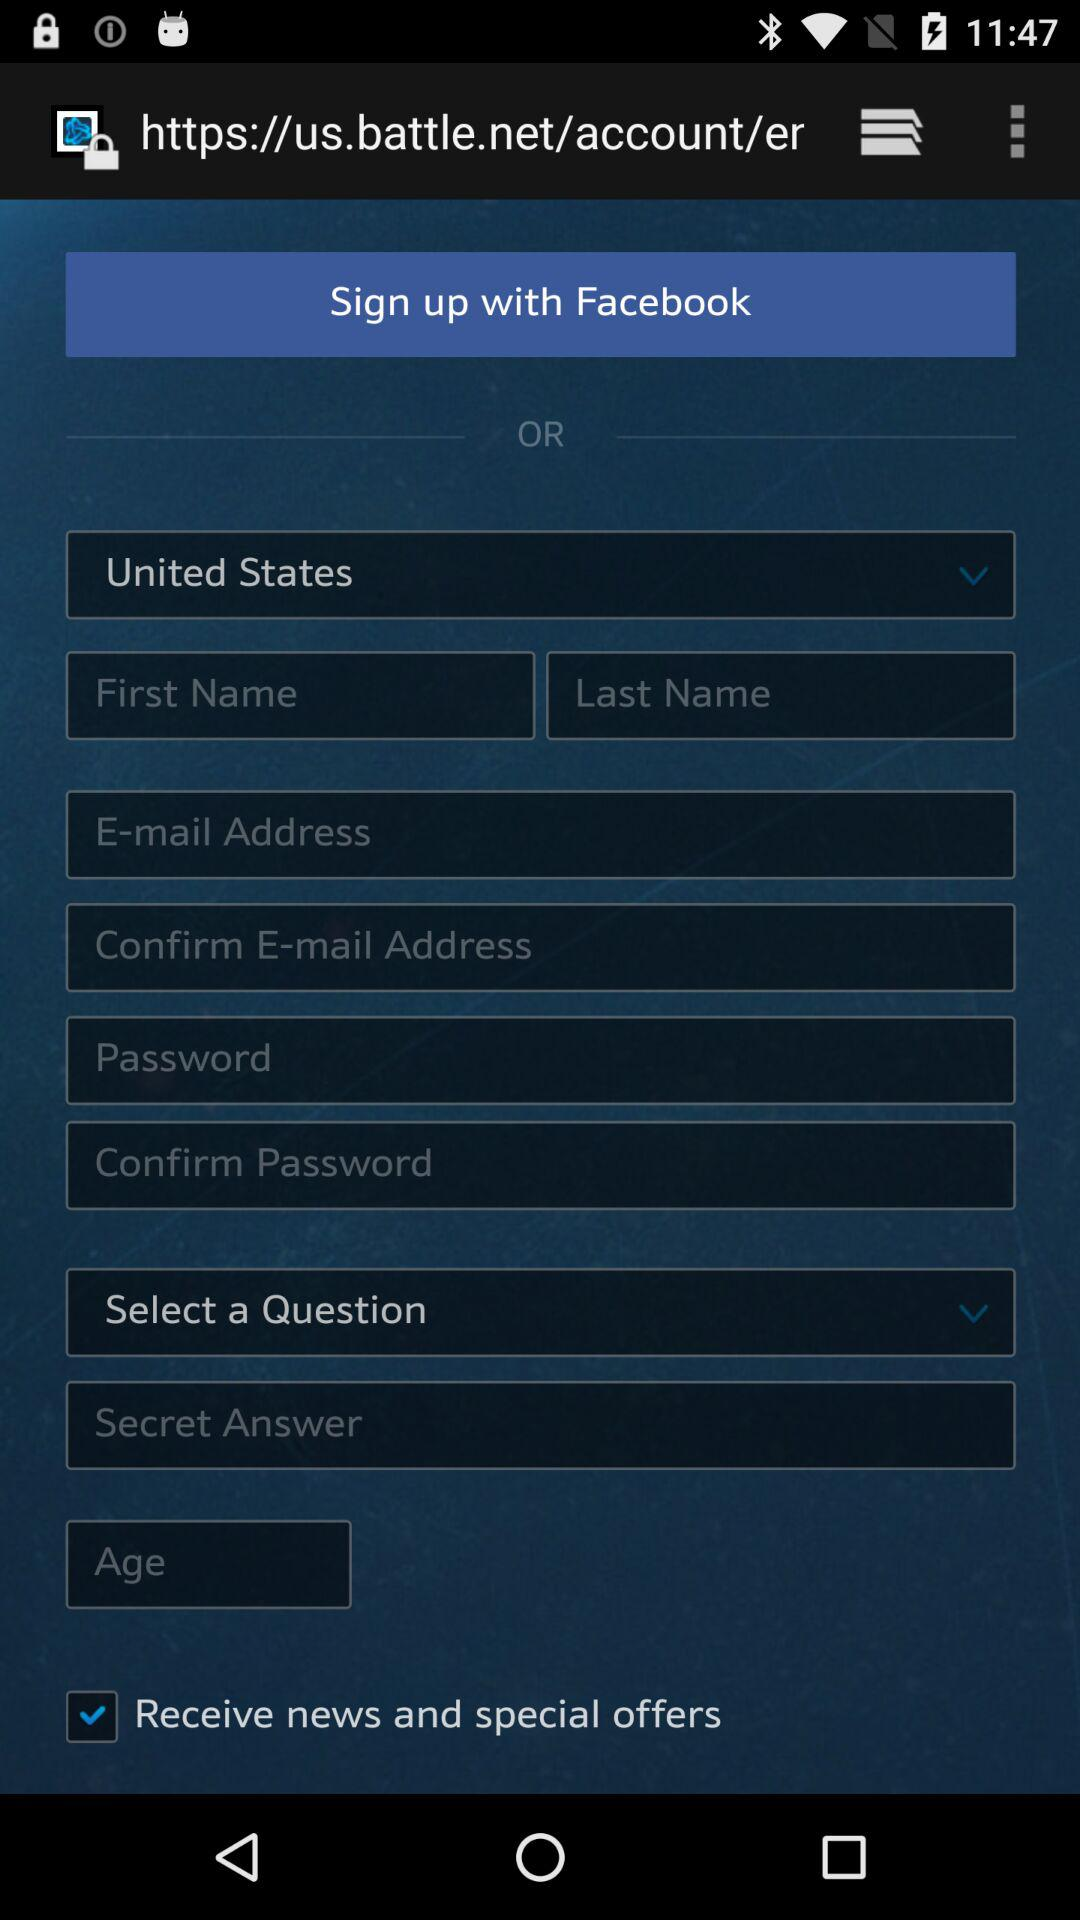Which country is selected? The selected country is the United States. 